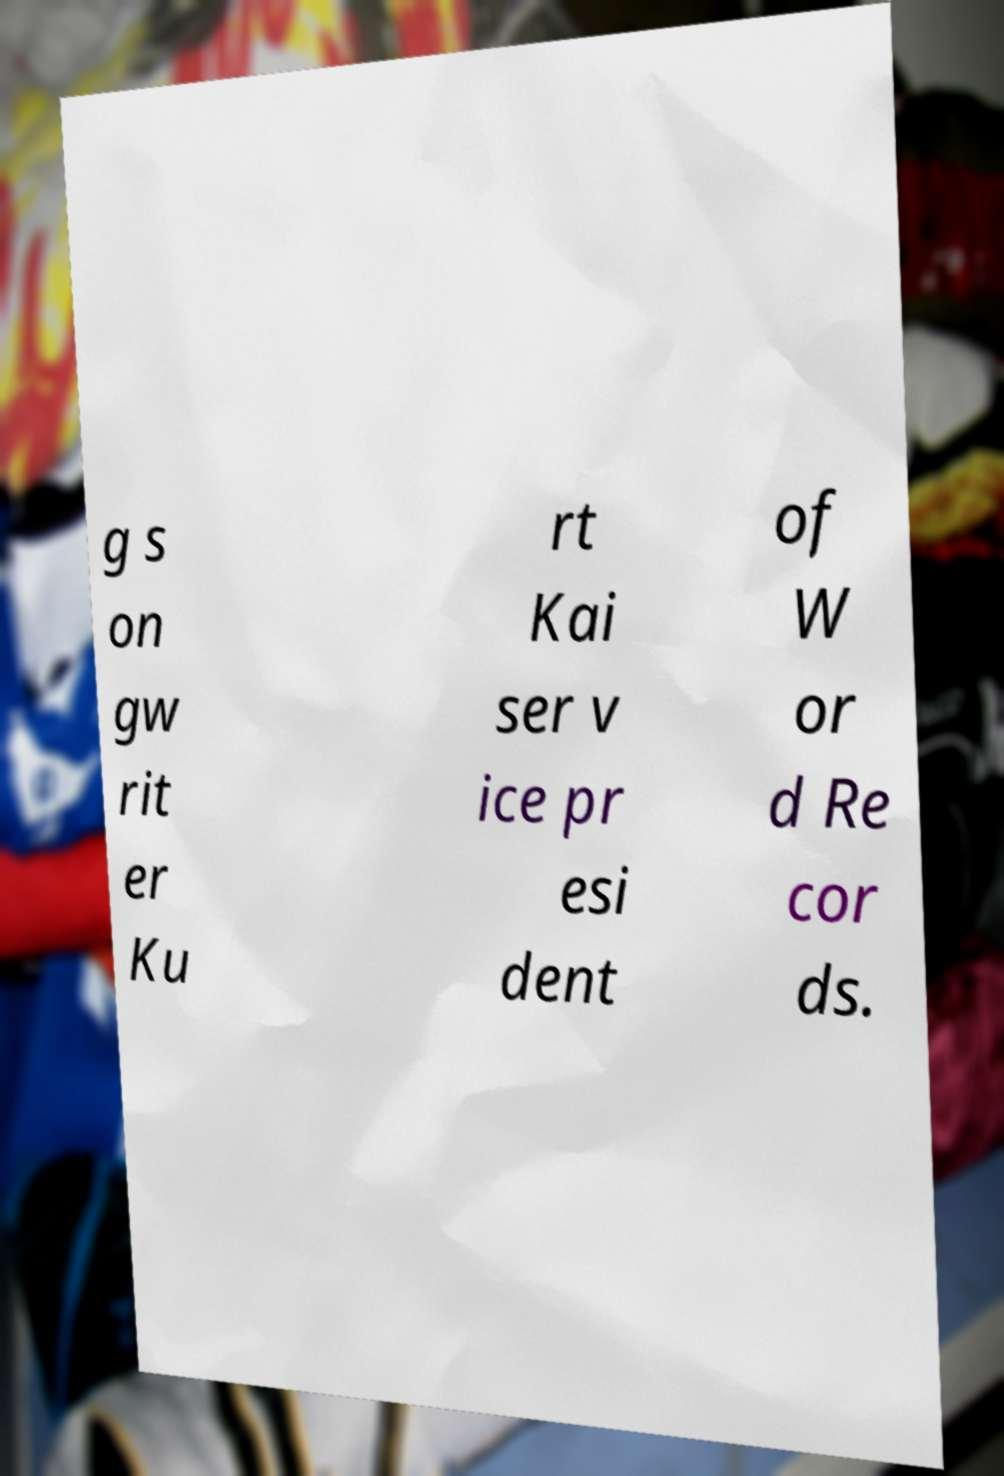Can you read and provide the text displayed in the image?This photo seems to have some interesting text. Can you extract and type it out for me? g s on gw rit er Ku rt Kai ser v ice pr esi dent of W or d Re cor ds. 